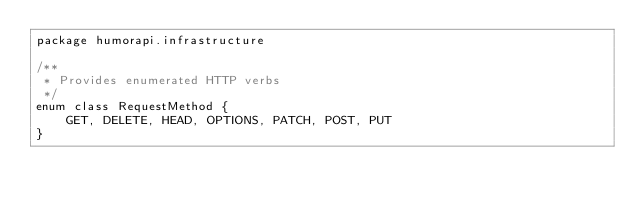<code> <loc_0><loc_0><loc_500><loc_500><_Kotlin_>package humorapi.infrastructure

/**
 * Provides enumerated HTTP verbs
 */
enum class RequestMethod {
    GET, DELETE, HEAD, OPTIONS, PATCH, POST, PUT
}</code> 